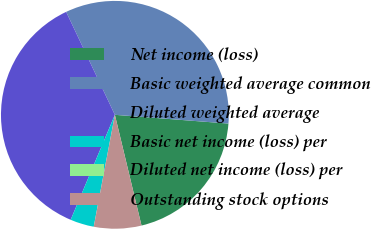Convert chart. <chart><loc_0><loc_0><loc_500><loc_500><pie_chart><fcel>Net income (loss)<fcel>Basic weighted average common<fcel>Diluted weighted average<fcel>Basic net income (loss) per<fcel>Diluted net income (loss) per<fcel>Outstanding stock options<nl><fcel>20.02%<fcel>33.26%<fcel>36.62%<fcel>3.37%<fcel>0.0%<fcel>6.73%<nl></chart> 